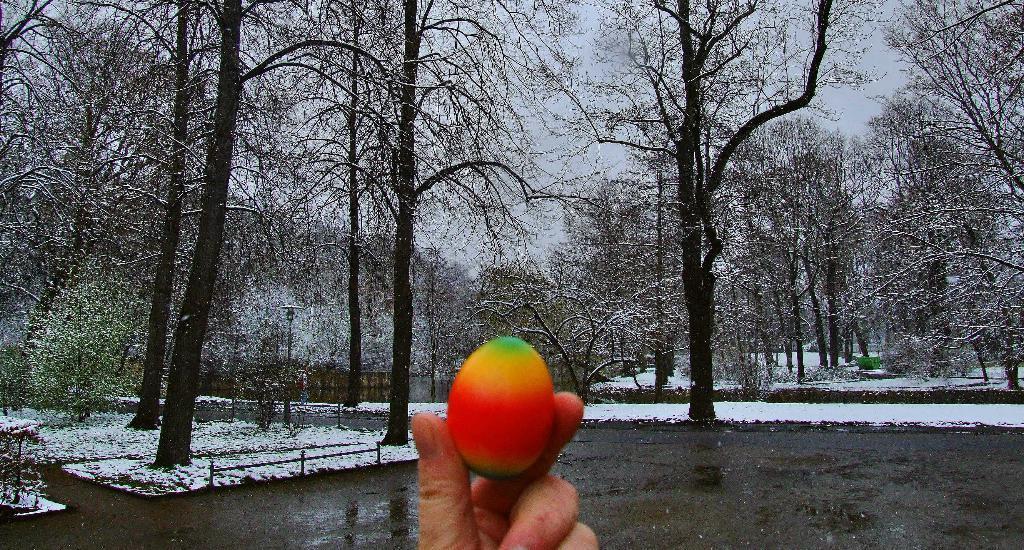In one or two sentences, can you explain what this image depicts? In this image, we can see a person's hand holding an object. We can see the ground with some objects. We can see some snow, a pole, trees, plants and the wall. We can also see the sky. 